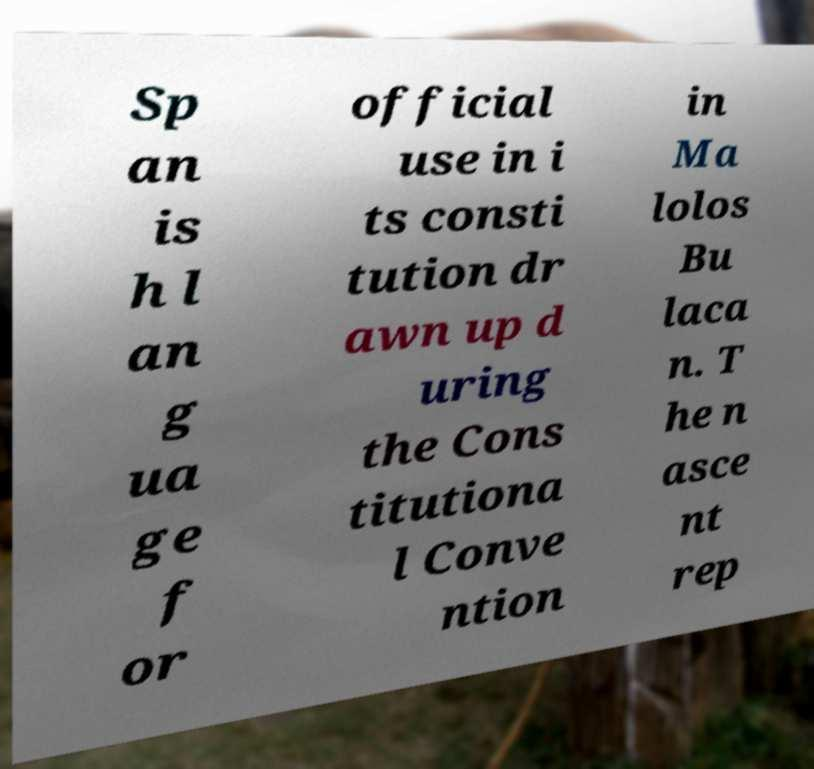There's text embedded in this image that I need extracted. Can you transcribe it verbatim? Sp an is h l an g ua ge f or official use in i ts consti tution dr awn up d uring the Cons titutiona l Conve ntion in Ma lolos Bu laca n. T he n asce nt rep 